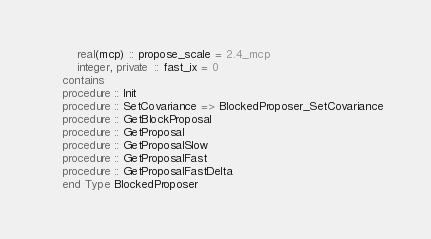Convert code to text. <code><loc_0><loc_0><loc_500><loc_500><_FORTRAN_>        real(mcp) :: propose_scale = 2.4_mcp
        integer, private  :: fast_ix = 0
    contains
    procedure :: Init
    procedure :: SetCovariance => BlockedProposer_SetCovariance
    procedure :: GetBlockProposal
    procedure :: GetProposal
    procedure :: GetProposalSlow
    procedure :: GetProposalFast
    procedure :: GetProposalFastDelta
    end Type BlockedProposer
</code> 